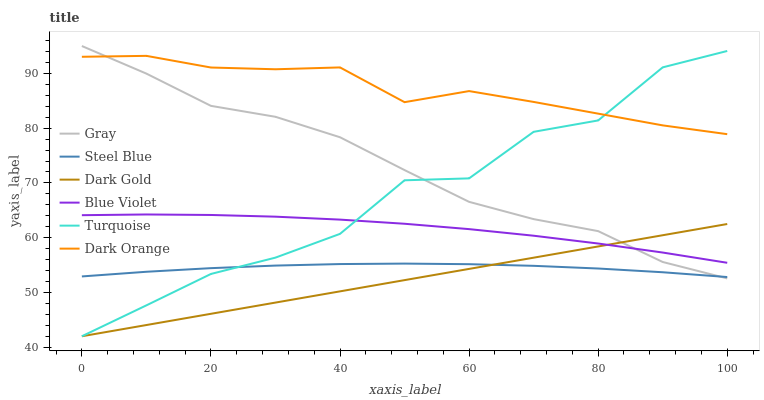Does Dark Gold have the minimum area under the curve?
Answer yes or no. Yes. Does Dark Orange have the maximum area under the curve?
Answer yes or no. Yes. Does Turquoise have the minimum area under the curve?
Answer yes or no. No. Does Turquoise have the maximum area under the curve?
Answer yes or no. No. Is Dark Gold the smoothest?
Answer yes or no. Yes. Is Turquoise the roughest?
Answer yes or no. Yes. Is Gray the smoothest?
Answer yes or no. No. Is Gray the roughest?
Answer yes or no. No. Does Turquoise have the lowest value?
Answer yes or no. Yes. Does Gray have the lowest value?
Answer yes or no. No. Does Gray have the highest value?
Answer yes or no. Yes. Does Turquoise have the highest value?
Answer yes or no. No. Is Steel Blue less than Blue Violet?
Answer yes or no. Yes. Is Dark Orange greater than Dark Gold?
Answer yes or no. Yes. Does Steel Blue intersect Gray?
Answer yes or no. Yes. Is Steel Blue less than Gray?
Answer yes or no. No. Is Steel Blue greater than Gray?
Answer yes or no. No. Does Steel Blue intersect Blue Violet?
Answer yes or no. No. 